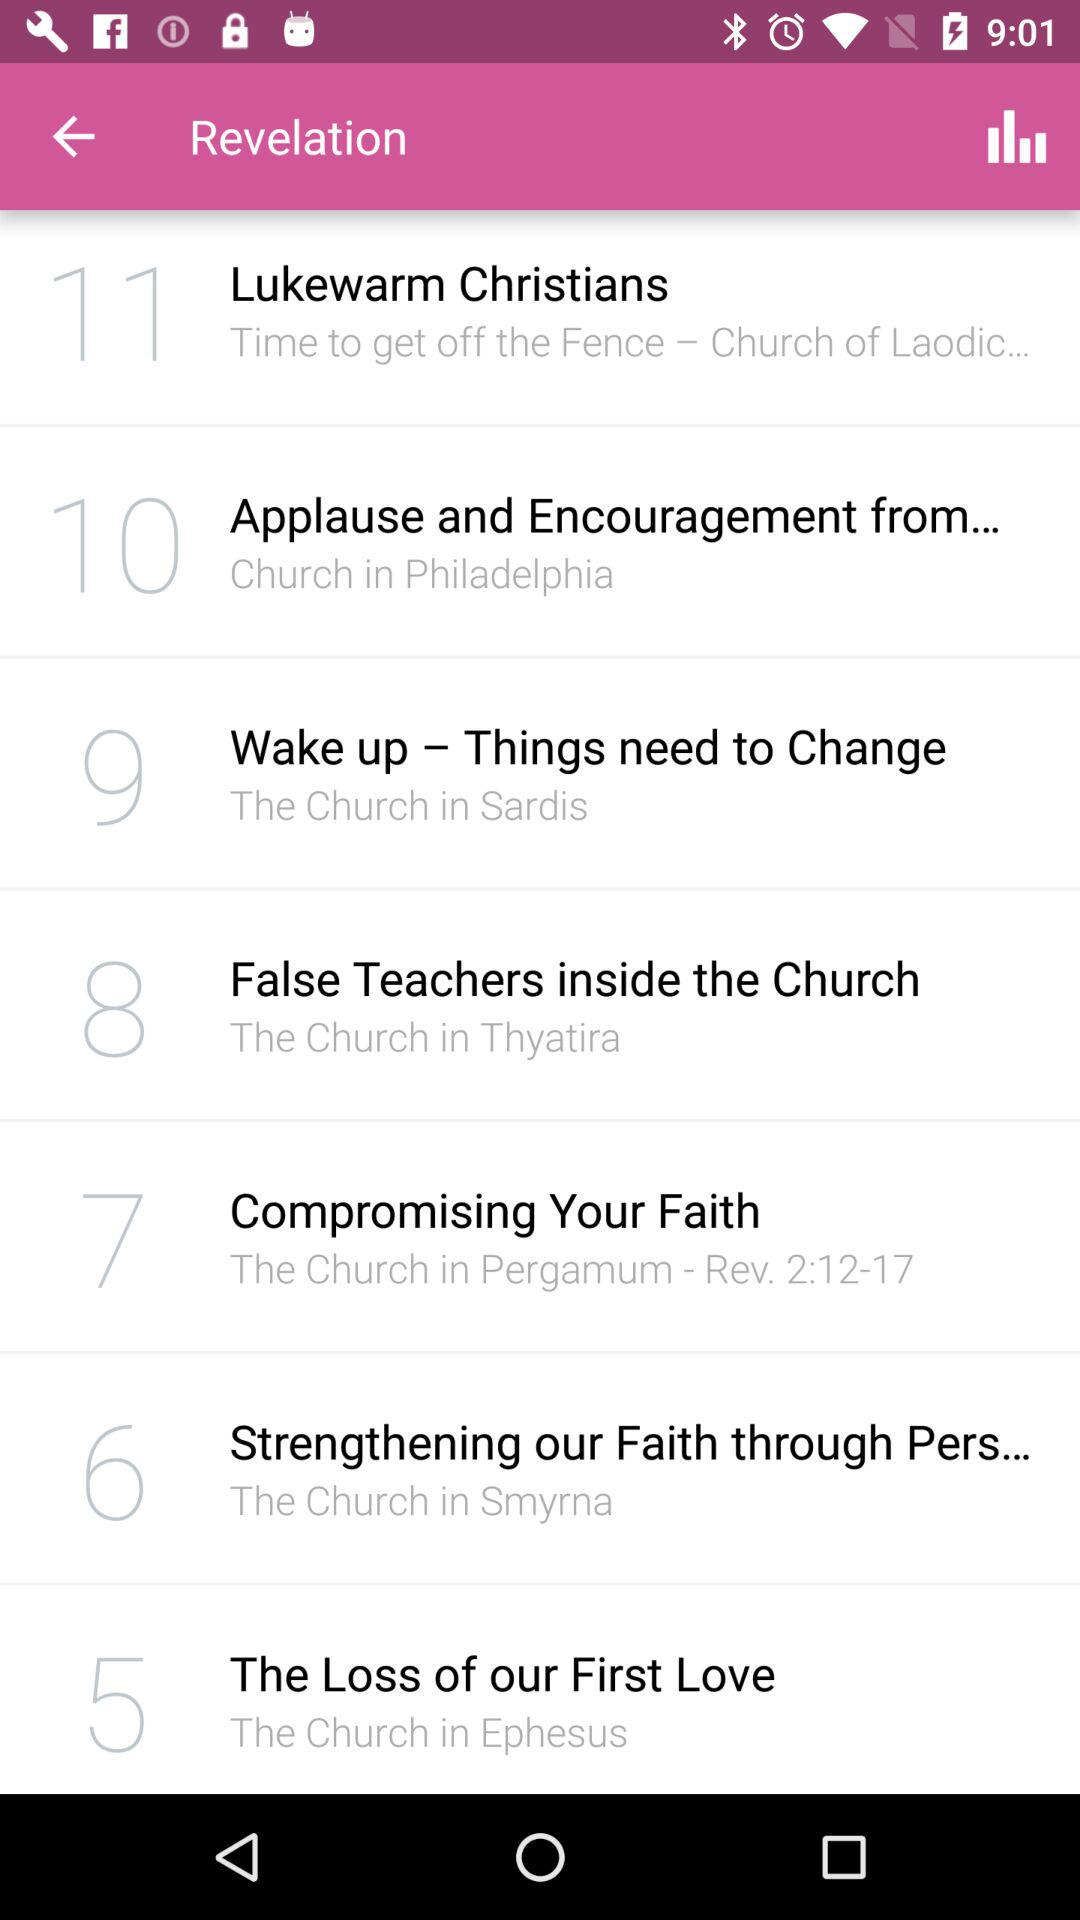What is the serial number for "The Loss of our First Love"? The serial number is 5. 